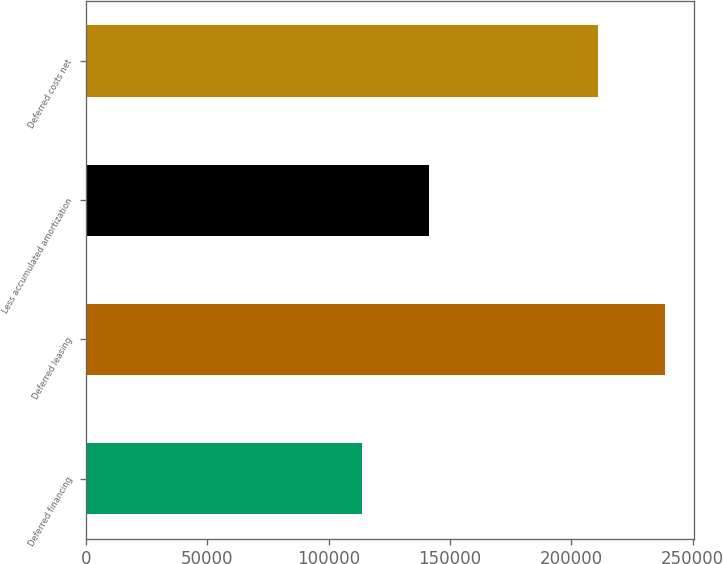Convert chart to OTSL. <chart><loc_0><loc_0><loc_500><loc_500><bar_chart><fcel>Deferred financing<fcel>Deferred leasing<fcel>Less accumulated amortization<fcel>Deferred costs net<nl><fcel>113620<fcel>238394<fcel>141228<fcel>210786<nl></chart> 